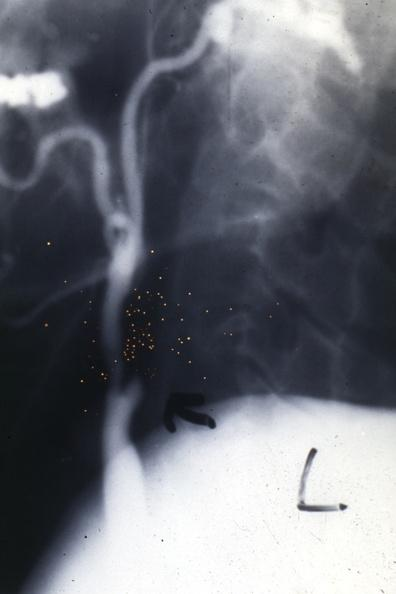does this image show carotid sclerosing panarteritis?
Answer the question using a single word or phrase. Yes 